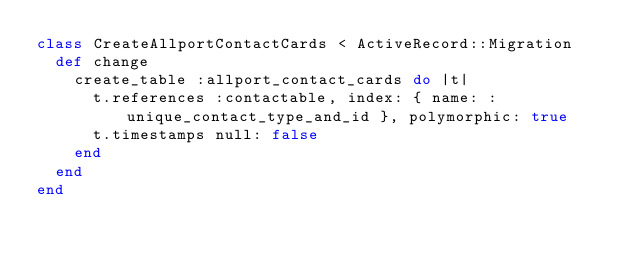Convert code to text. <code><loc_0><loc_0><loc_500><loc_500><_Ruby_>class CreateAllportContactCards < ActiveRecord::Migration
  def change
    create_table :allport_contact_cards do |t|
      t.references :contactable, index: { name: :unique_contact_type_and_id }, polymorphic: true
      t.timestamps null: false
    end
  end
end
</code> 